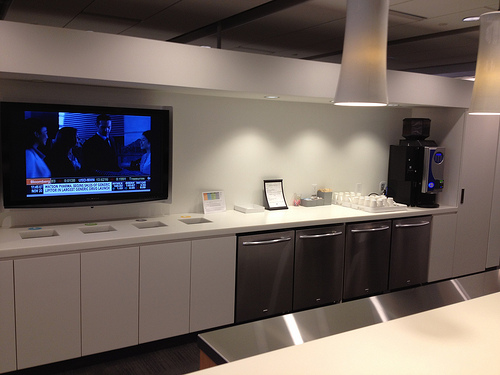Please provide a short description for this region: [0.48, 0.55, 0.85, 0.76]. In this area, you can see cabinets made of metal. 